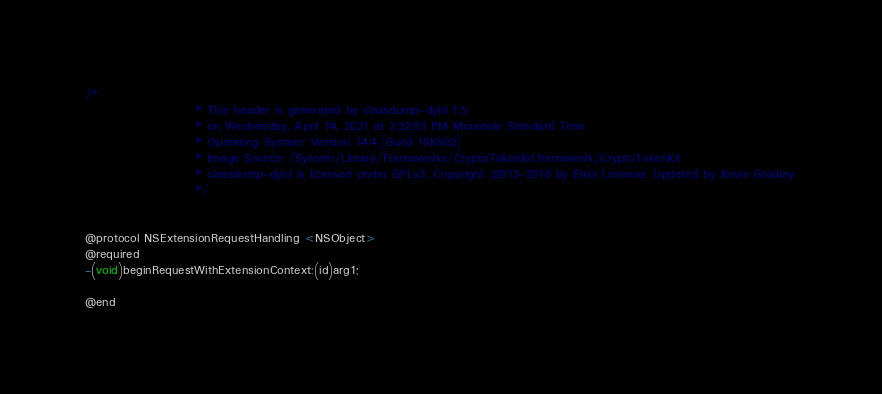Convert code to text. <code><loc_0><loc_0><loc_500><loc_500><_C_>/*
                       * This header is generated by classdump-dyld 1.5
                       * on Wednesday, April 14, 2021 at 2:32:03 PM Mountain Standard Time
                       * Operating System: Version 14.4 (Build 18K802)
                       * Image Source: /System/Library/Frameworks/CryptoTokenKit.framework/CryptoTokenKit
                       * classdump-dyld is licensed under GPLv3, Copyright © 2013-2016 by Elias Limneos. Updated by Kevin Bradley.
                       */


@protocol NSExtensionRequestHandling <NSObject>
@required
-(void)beginRequestWithExtensionContext:(id)arg1;

@end

</code> 